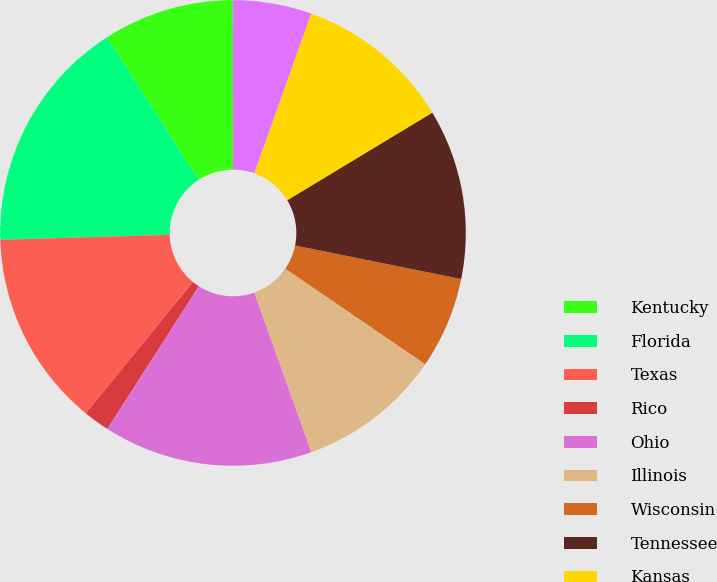Convert chart to OTSL. <chart><loc_0><loc_0><loc_500><loc_500><pie_chart><fcel>Kentucky<fcel>Florida<fcel>Texas<fcel>Rico<fcel>Ohio<fcel>Illinois<fcel>Wisconsin<fcel>Tennessee<fcel>Kansas<fcel>Georgia<nl><fcel>9.09%<fcel>16.36%<fcel>13.64%<fcel>1.82%<fcel>14.54%<fcel>10.0%<fcel>6.36%<fcel>11.82%<fcel>10.91%<fcel>5.46%<nl></chart> 